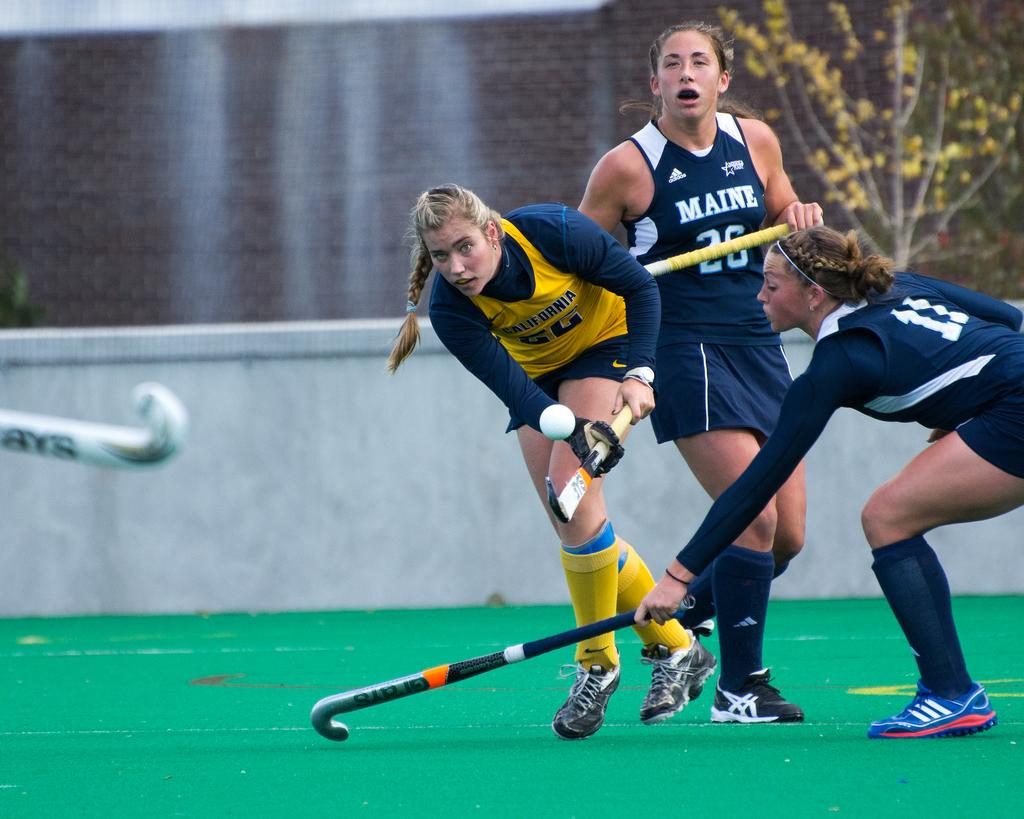<image>
Write a terse but informative summary of the picture. Girls from the state of Maine are playing indoor field hockey. 